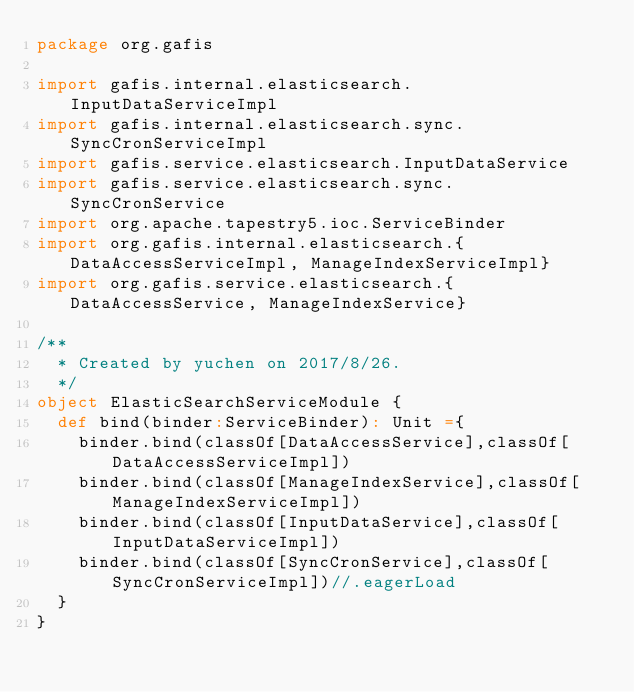<code> <loc_0><loc_0><loc_500><loc_500><_Scala_>package org.gafis

import gafis.internal.elasticsearch.InputDataServiceImpl
import gafis.internal.elasticsearch.sync.SyncCronServiceImpl
import gafis.service.elasticsearch.InputDataService
import gafis.service.elasticsearch.sync.SyncCronService
import org.apache.tapestry5.ioc.ServiceBinder
import org.gafis.internal.elasticsearch.{DataAccessServiceImpl, ManageIndexServiceImpl}
import org.gafis.service.elasticsearch.{DataAccessService, ManageIndexService}

/**
  * Created by yuchen on 2017/8/26.
  */
object ElasticSearchServiceModule {
  def bind(binder:ServiceBinder): Unit ={
    binder.bind(classOf[DataAccessService],classOf[DataAccessServiceImpl])
    binder.bind(classOf[ManageIndexService],classOf[ManageIndexServiceImpl])
    binder.bind(classOf[InputDataService],classOf[InputDataServiceImpl])
    binder.bind(classOf[SyncCronService],classOf[SyncCronServiceImpl])//.eagerLoad
  }
}
</code> 